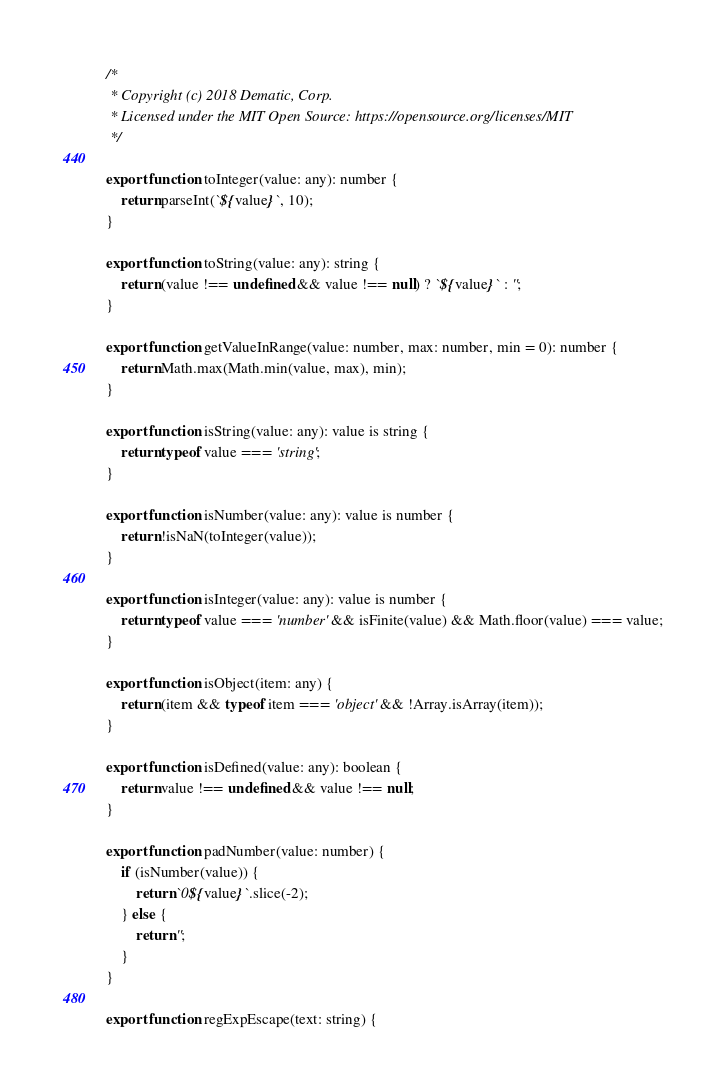Convert code to text. <code><loc_0><loc_0><loc_500><loc_500><_TypeScript_>/*
 * Copyright (c) 2018 Dematic, Corp.
 * Licensed under the MIT Open Source: https://opensource.org/licenses/MIT
 */

export function toInteger(value: any): number {
    return parseInt(`${value}`, 10);
}

export function toString(value: any): string {
    return (value !== undefined && value !== null) ? `${value}` : '';
}

export function getValueInRange(value: number, max: number, min = 0): number {
    return Math.max(Math.min(value, max), min);
}

export function isString(value: any): value is string {
    return typeof value === 'string';
}

export function isNumber(value: any): value is number {
    return !isNaN(toInteger(value));
}

export function isInteger(value: any): value is number {
    return typeof value === 'number' && isFinite(value) && Math.floor(value) === value;
}

export function isObject(item: any) {
    return (item && typeof item === 'object' && !Array.isArray(item));
}

export function isDefined(value: any): boolean {
    return value !== undefined && value !== null;
}

export function padNumber(value: number) {
    if (isNumber(value)) {
        return `0${value}`.slice(-2);
    } else {
        return '';
    }
}

export function regExpEscape(text: string) {</code> 